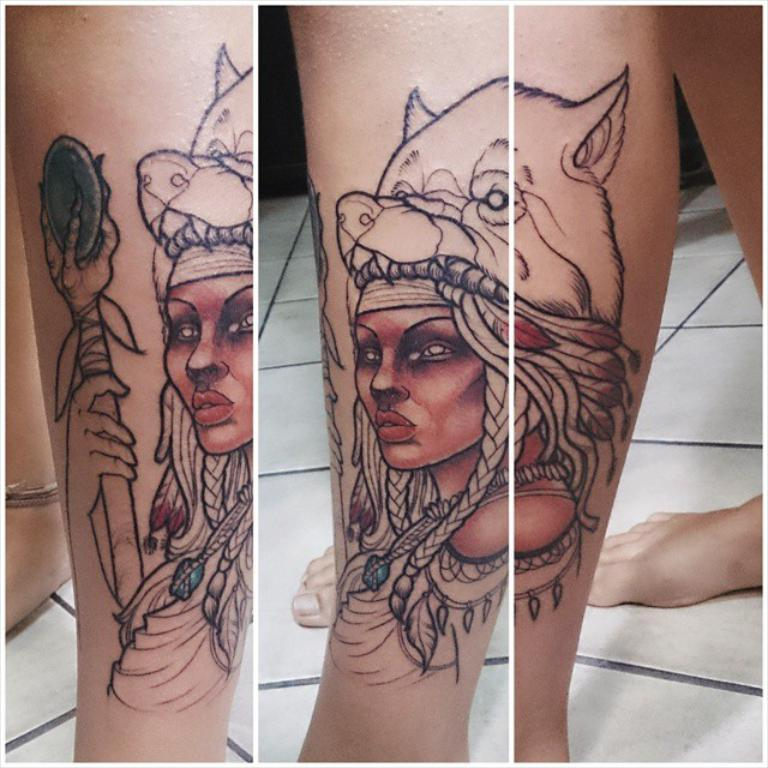What part of a person's body is visible in the image? There is a person's leg in the image. Can you describe any distinguishing features on the leg? The person's leg has a tattoo. What type of wine is being served in the image? There is no wine present in the image; it only features a person's leg with a tattoo. How does the giraffe interact with the person's leg in the image? There is no giraffe present in the image, so it cannot interact with the person's leg. 